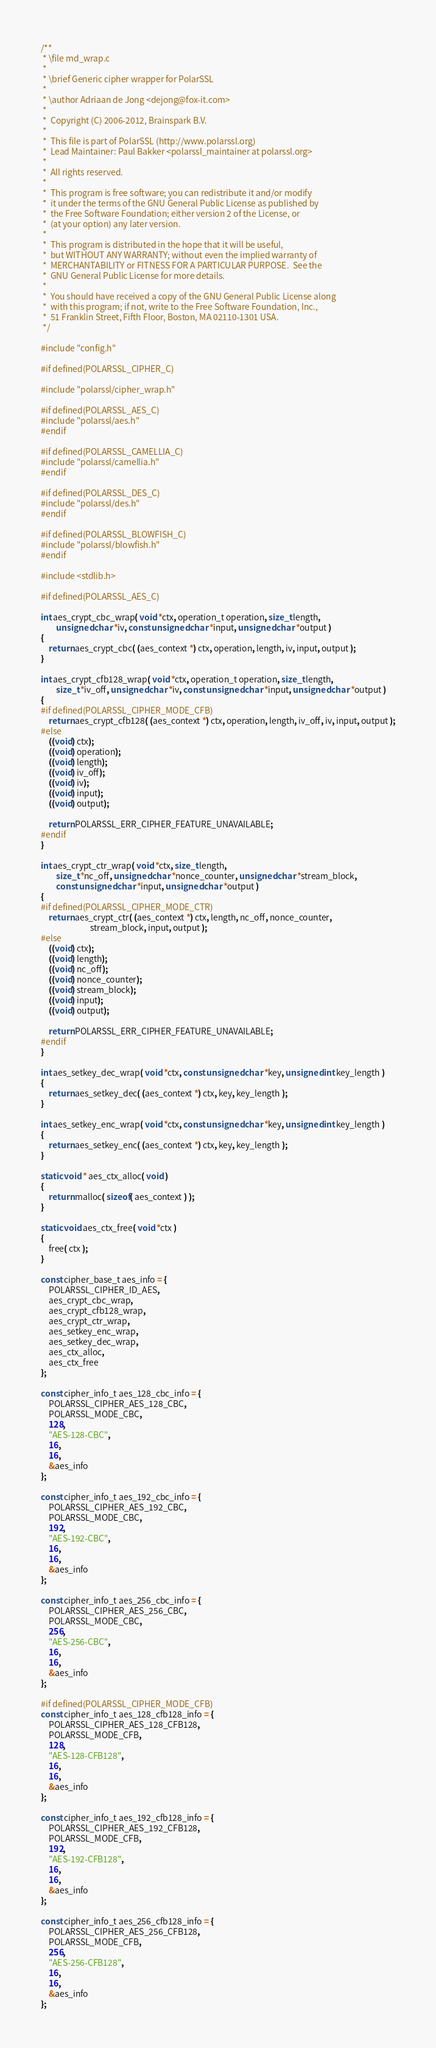Convert code to text. <code><loc_0><loc_0><loc_500><loc_500><_C_>/**
 * \file md_wrap.c
 * 
 * \brief Generic cipher wrapper for PolarSSL
 *
 * \author Adriaan de Jong <dejong@fox-it.com>
 *
 *  Copyright (C) 2006-2012, Brainspark B.V.
 *
 *  This file is part of PolarSSL (http://www.polarssl.org)
 *  Lead Maintainer: Paul Bakker <polarssl_maintainer at polarssl.org>
 *
 *  All rights reserved.
 *
 *  This program is free software; you can redistribute it and/or modify
 *  it under the terms of the GNU General Public License as published by
 *  the Free Software Foundation; either version 2 of the License, or
 *  (at your option) any later version.
 *
 *  This program is distributed in the hope that it will be useful,
 *  but WITHOUT ANY WARRANTY; without even the implied warranty of
 *  MERCHANTABILITY or FITNESS FOR A PARTICULAR PURPOSE.  See the
 *  GNU General Public License for more details.
 *
 *  You should have received a copy of the GNU General Public License along
 *  with this program; if not, write to the Free Software Foundation, Inc.,
 *  51 Franklin Street, Fifth Floor, Boston, MA 02110-1301 USA.
 */

#include "config.h"

#if defined(POLARSSL_CIPHER_C)

#include "polarssl/cipher_wrap.h"

#if defined(POLARSSL_AES_C)
#include "polarssl/aes.h"
#endif

#if defined(POLARSSL_CAMELLIA_C)
#include "polarssl/camellia.h"
#endif

#if defined(POLARSSL_DES_C)
#include "polarssl/des.h"
#endif

#if defined(POLARSSL_BLOWFISH_C)
#include "polarssl/blowfish.h"
#endif

#include <stdlib.h>

#if defined(POLARSSL_AES_C)

int aes_crypt_cbc_wrap( void *ctx, operation_t operation, size_t length,
        unsigned char *iv, const unsigned char *input, unsigned char *output )
{
    return aes_crypt_cbc( (aes_context *) ctx, operation, length, iv, input, output );
}

int aes_crypt_cfb128_wrap( void *ctx, operation_t operation, size_t length,
        size_t *iv_off, unsigned char *iv, const unsigned char *input, unsigned char *output )
{
#if defined(POLARSSL_CIPHER_MODE_CFB)
    return aes_crypt_cfb128( (aes_context *) ctx, operation, length, iv_off, iv, input, output );
#else
    ((void) ctx);
    ((void) operation);
    ((void) length);
    ((void) iv_off);
    ((void) iv);
    ((void) input);
    ((void) output);

    return POLARSSL_ERR_CIPHER_FEATURE_UNAVAILABLE;
#endif
}

int aes_crypt_ctr_wrap( void *ctx, size_t length,
        size_t *nc_off, unsigned char *nonce_counter, unsigned char *stream_block,
        const unsigned char *input, unsigned char *output )
{
#if defined(POLARSSL_CIPHER_MODE_CTR)
    return aes_crypt_ctr( (aes_context *) ctx, length, nc_off, nonce_counter,
                          stream_block, input, output );
#else
    ((void) ctx);
    ((void) length);
    ((void) nc_off);
    ((void) nonce_counter);
    ((void) stream_block);
    ((void) input);
    ((void) output);

    return POLARSSL_ERR_CIPHER_FEATURE_UNAVAILABLE;
#endif
}

int aes_setkey_dec_wrap( void *ctx, const unsigned char *key, unsigned int key_length )
{
    return aes_setkey_dec( (aes_context *) ctx, key, key_length );
}

int aes_setkey_enc_wrap( void *ctx, const unsigned char *key, unsigned int key_length )
{
    return aes_setkey_enc( (aes_context *) ctx, key, key_length );
}

static void * aes_ctx_alloc( void )
{
    return malloc( sizeof( aes_context ) );
}

static void aes_ctx_free( void *ctx )
{
    free( ctx );
}

const cipher_base_t aes_info = {
    POLARSSL_CIPHER_ID_AES,
    aes_crypt_cbc_wrap,
    aes_crypt_cfb128_wrap,
    aes_crypt_ctr_wrap,
    aes_setkey_enc_wrap,
    aes_setkey_dec_wrap,
    aes_ctx_alloc,
    aes_ctx_free
};

const cipher_info_t aes_128_cbc_info = {
    POLARSSL_CIPHER_AES_128_CBC,
    POLARSSL_MODE_CBC,
    128,
    "AES-128-CBC",
    16,
    16,
    &aes_info
};

const cipher_info_t aes_192_cbc_info = {
    POLARSSL_CIPHER_AES_192_CBC,
    POLARSSL_MODE_CBC,
    192,
    "AES-192-CBC",
    16,
    16,
    &aes_info
};

const cipher_info_t aes_256_cbc_info = {
    POLARSSL_CIPHER_AES_256_CBC,
    POLARSSL_MODE_CBC,
    256,
    "AES-256-CBC",
    16,
    16,
    &aes_info
};

#if defined(POLARSSL_CIPHER_MODE_CFB)
const cipher_info_t aes_128_cfb128_info = {
    POLARSSL_CIPHER_AES_128_CFB128,
    POLARSSL_MODE_CFB,
    128,
    "AES-128-CFB128",
    16,
    16,
    &aes_info
};

const cipher_info_t aes_192_cfb128_info = {
    POLARSSL_CIPHER_AES_192_CFB128,
    POLARSSL_MODE_CFB,
    192,
    "AES-192-CFB128",
    16,
    16,
    &aes_info
};

const cipher_info_t aes_256_cfb128_info = {
    POLARSSL_CIPHER_AES_256_CFB128,
    POLARSSL_MODE_CFB,
    256,
    "AES-256-CFB128",
    16,
    16,
    &aes_info
};</code> 